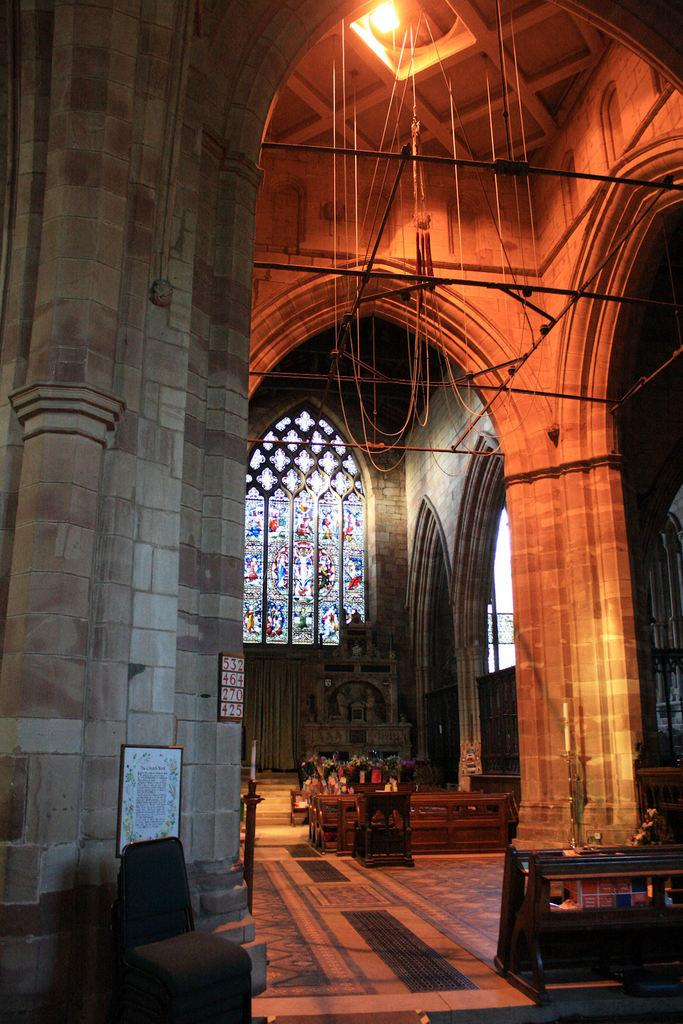What part of a building is shown in the image? The image shows the inner part of a building. What type of material is used for some of the objects in the image? There are wooden objects in the image. What can be seen providing illumination in the image? There are lights visible in the image. Is there any opening to the outside in the image? Yes, there is a window in the image. What type of weather can be seen through the window in the image? The image does not show any weather conditions, as it only depicts the inner part of a building. 